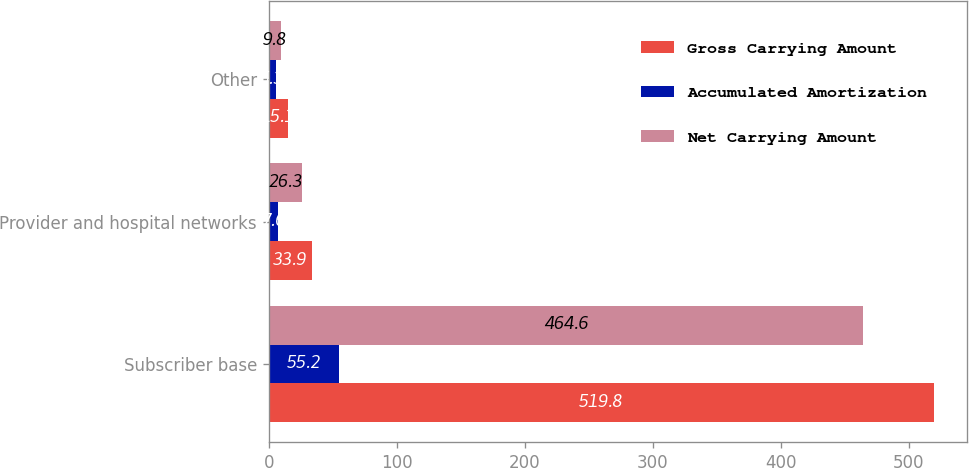Convert chart to OTSL. <chart><loc_0><loc_0><loc_500><loc_500><stacked_bar_chart><ecel><fcel>Subscriber base<fcel>Provider and hospital networks<fcel>Other<nl><fcel>Gross Carrying Amount<fcel>519.8<fcel>33.9<fcel>15.1<nl><fcel>Accumulated Amortization<fcel>55.2<fcel>7.6<fcel>5.3<nl><fcel>Net Carrying Amount<fcel>464.6<fcel>26.3<fcel>9.8<nl></chart> 